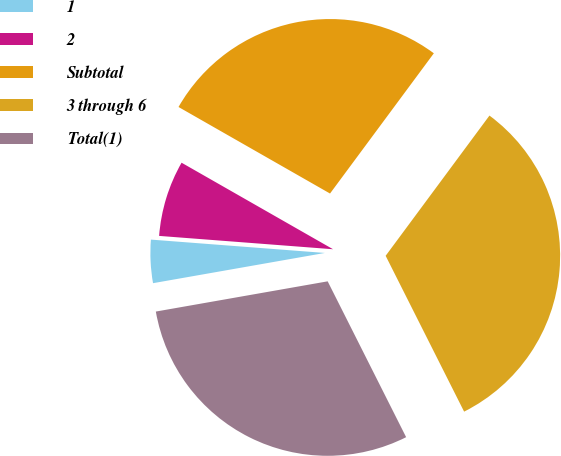Convert chart. <chart><loc_0><loc_0><loc_500><loc_500><pie_chart><fcel>1<fcel>2<fcel>Subtotal<fcel>3 through 6<fcel>Total(1)<nl><fcel>3.99%<fcel>7.04%<fcel>26.88%<fcel>32.43%<fcel>29.65%<nl></chart> 